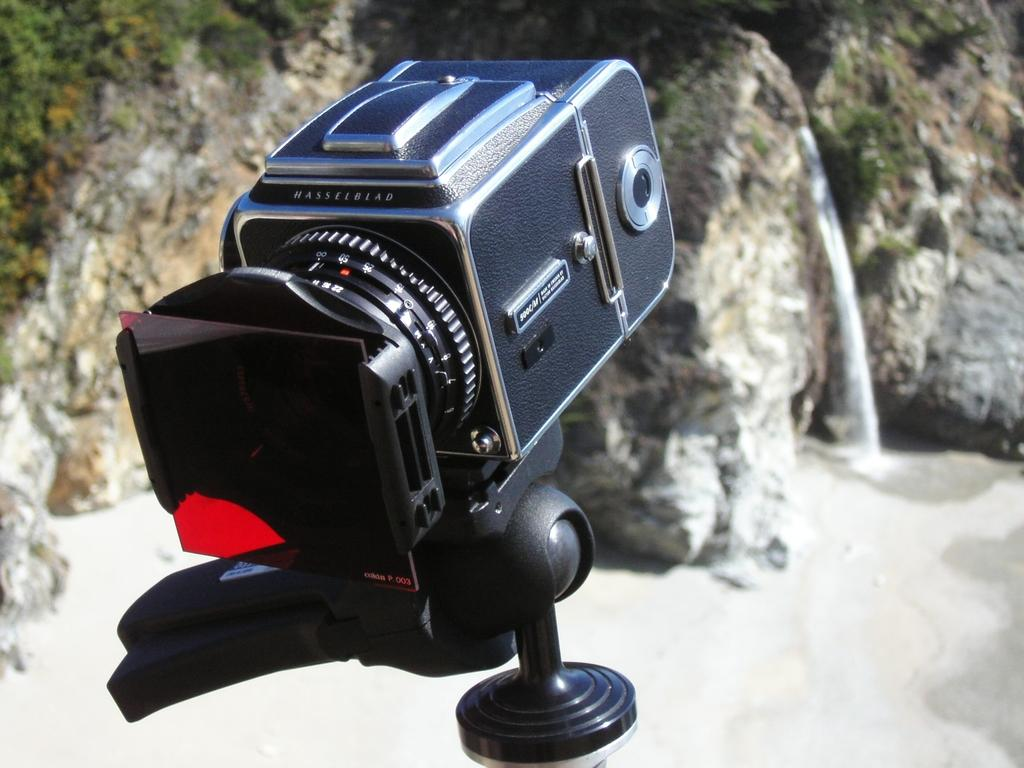What object is the main focus of the image? There is a camera in the image. What can be seen in the background of the image? There are plants, rocks, and water visible in the background of the image. What type of clam is being photographed by the camera in the image? There is no clam present in the image; the main subject is a camera. 